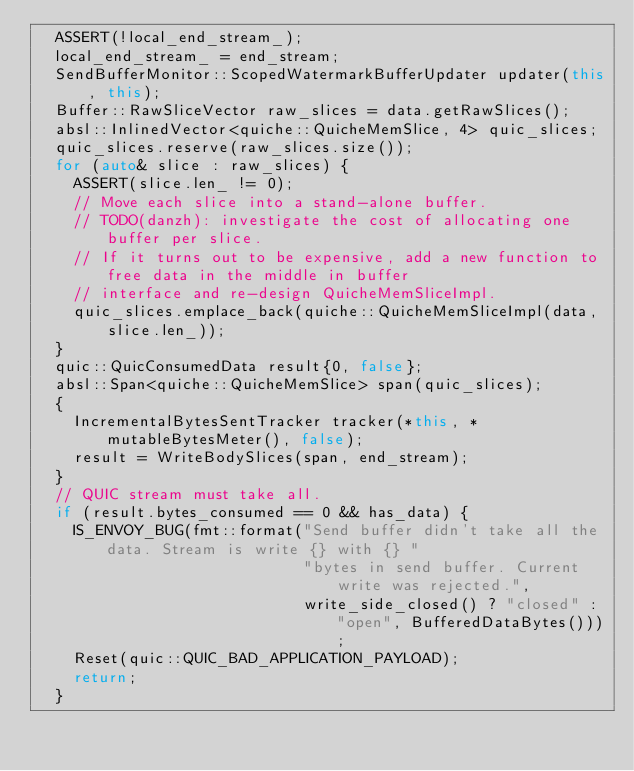Convert code to text. <code><loc_0><loc_0><loc_500><loc_500><_C++_>  ASSERT(!local_end_stream_);
  local_end_stream_ = end_stream;
  SendBufferMonitor::ScopedWatermarkBufferUpdater updater(this, this);
  Buffer::RawSliceVector raw_slices = data.getRawSlices();
  absl::InlinedVector<quiche::QuicheMemSlice, 4> quic_slices;
  quic_slices.reserve(raw_slices.size());
  for (auto& slice : raw_slices) {
    ASSERT(slice.len_ != 0);
    // Move each slice into a stand-alone buffer.
    // TODO(danzh): investigate the cost of allocating one buffer per slice.
    // If it turns out to be expensive, add a new function to free data in the middle in buffer
    // interface and re-design QuicheMemSliceImpl.
    quic_slices.emplace_back(quiche::QuicheMemSliceImpl(data, slice.len_));
  }
  quic::QuicConsumedData result{0, false};
  absl::Span<quiche::QuicheMemSlice> span(quic_slices);
  {
    IncrementalBytesSentTracker tracker(*this, *mutableBytesMeter(), false);
    result = WriteBodySlices(span, end_stream);
  }
  // QUIC stream must take all.
  if (result.bytes_consumed == 0 && has_data) {
    IS_ENVOY_BUG(fmt::format("Send buffer didn't take all the data. Stream is write {} with {} "
                             "bytes in send buffer. Current write was rejected.",
                             write_side_closed() ? "closed" : "open", BufferedDataBytes()));
    Reset(quic::QUIC_BAD_APPLICATION_PAYLOAD);
    return;
  }</code> 